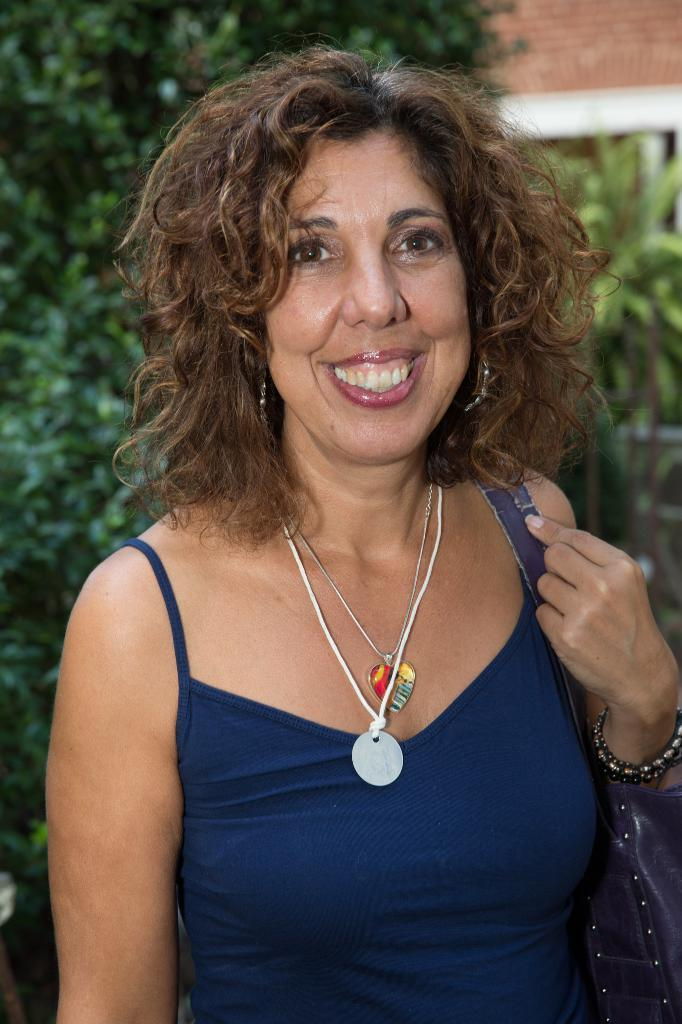Who is present in the image? There is a woman in the image. What is the woman doing in the image? The woman is standing and smiling. What is the woman holding or carrying in the image? The woman is carrying a bag. What can be seen in the background of the image? There are trees and a roof top visible in the background of the image. How many mice are climbing on the canvas in the image? There is no canvas or mice present in the image. 